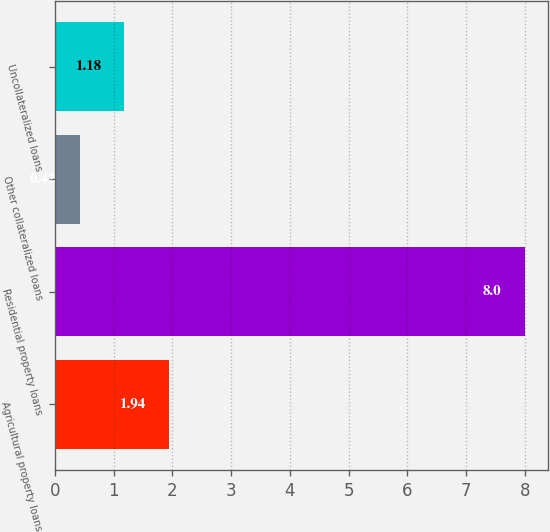Convert chart. <chart><loc_0><loc_0><loc_500><loc_500><bar_chart><fcel>Agricultural property loans<fcel>Residential property loans<fcel>Other collateralized loans<fcel>Uncollateralized loans<nl><fcel>1.94<fcel>8<fcel>0.42<fcel>1.18<nl></chart> 